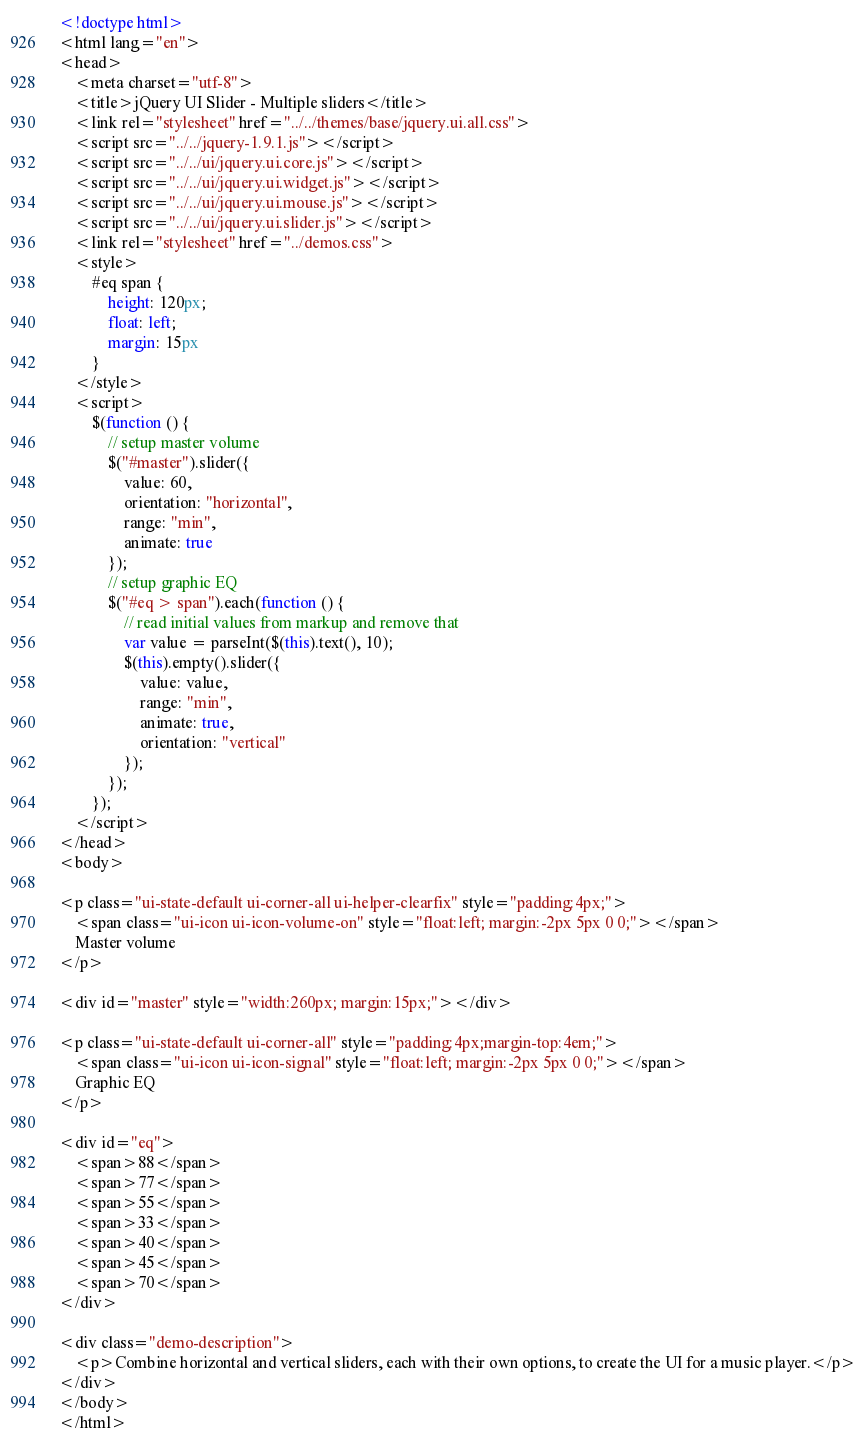<code> <loc_0><loc_0><loc_500><loc_500><_HTML_><!doctype html>
<html lang="en">
<head>
    <meta charset="utf-8">
    <title>jQuery UI Slider - Multiple sliders</title>
    <link rel="stylesheet" href="../../themes/base/jquery.ui.all.css">
    <script src="../../jquery-1.9.1.js"></script>
    <script src="../../ui/jquery.ui.core.js"></script>
    <script src="../../ui/jquery.ui.widget.js"></script>
    <script src="../../ui/jquery.ui.mouse.js"></script>
    <script src="../../ui/jquery.ui.slider.js"></script>
    <link rel="stylesheet" href="../demos.css">
    <style>
        #eq span {
            height: 120px;
            float: left;
            margin: 15px
        }
    </style>
    <script>
        $(function () {
            // setup master volume
            $("#master").slider({
                value: 60,
                orientation: "horizontal",
                range: "min",
                animate: true
            });
            // setup graphic EQ
            $("#eq > span").each(function () {
                // read initial values from markup and remove that
                var value = parseInt($(this).text(), 10);
                $(this).empty().slider({
                    value: value,
                    range: "min",
                    animate: true,
                    orientation: "vertical"
                });
            });
        });
    </script>
</head>
<body>

<p class="ui-state-default ui-corner-all ui-helper-clearfix" style="padding:4px;">
    <span class="ui-icon ui-icon-volume-on" style="float:left; margin:-2px 5px 0 0;"></span>
    Master volume
</p>

<div id="master" style="width:260px; margin:15px;"></div>

<p class="ui-state-default ui-corner-all" style="padding:4px;margin-top:4em;">
    <span class="ui-icon ui-icon-signal" style="float:left; margin:-2px 5px 0 0;"></span>
    Graphic EQ
</p>

<div id="eq">
    <span>88</span>
    <span>77</span>
    <span>55</span>
    <span>33</span>
    <span>40</span>
    <span>45</span>
    <span>70</span>
</div>

<div class="demo-description">
    <p>Combine horizontal and vertical sliders, each with their own options, to create the UI for a music player.</p>
</div>
</body>
</html>
</code> 